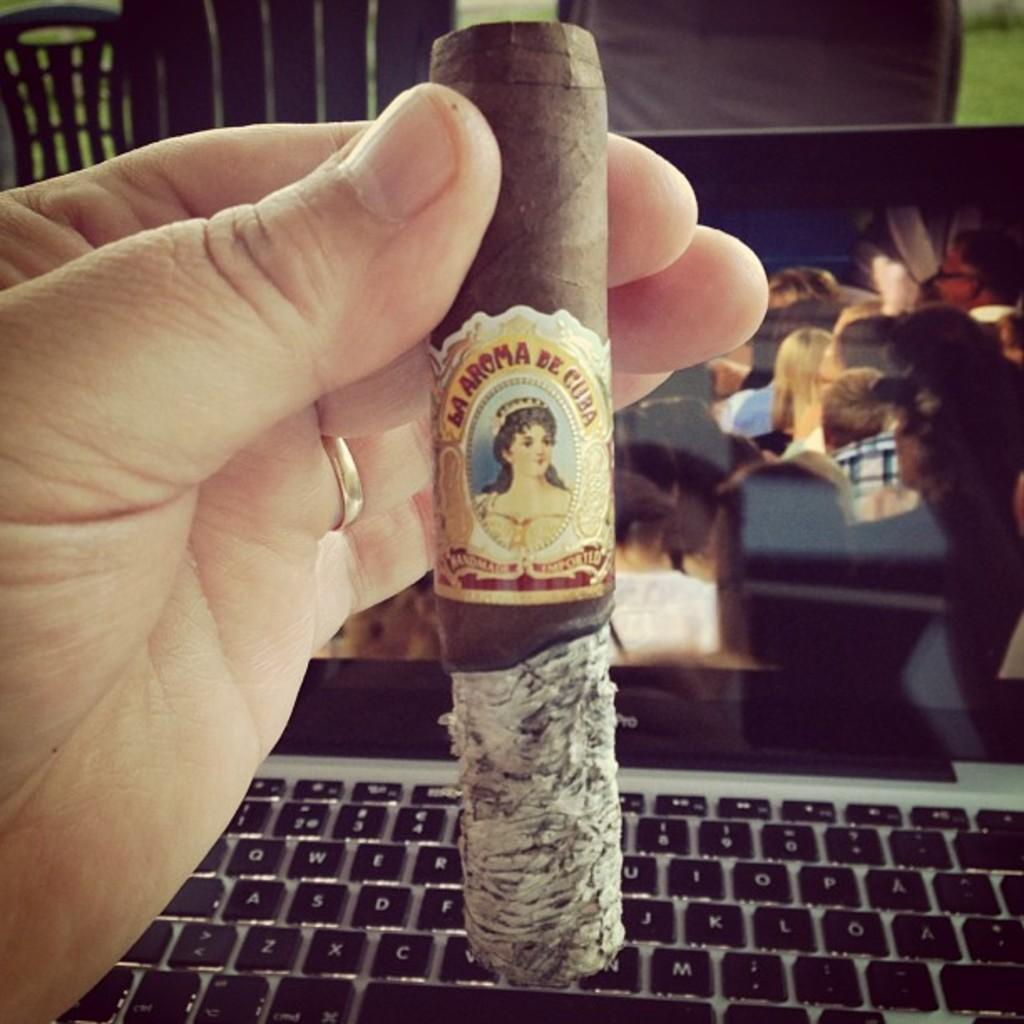<image>
Give a short and clear explanation of the subsequent image. a cigar reading La Aroma de Cuba held over a computer keyboard 